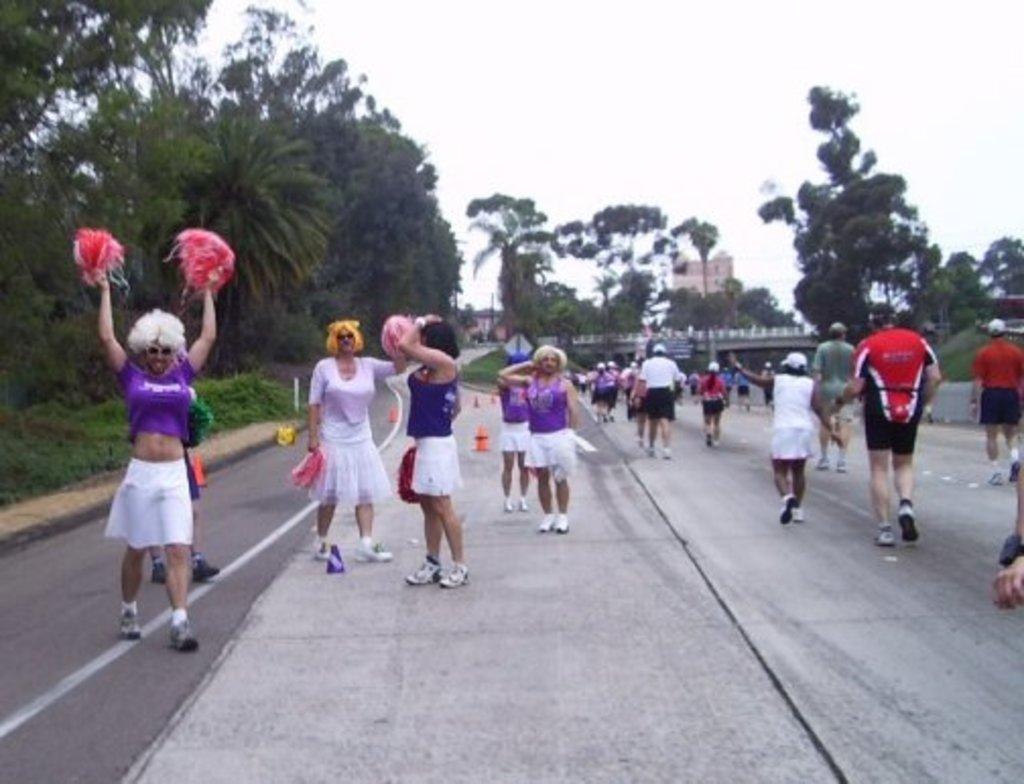How would you summarize this image in a sentence or two? As we can see in the image there are trees, buildings and few people here and there. On the top there is a sky. 